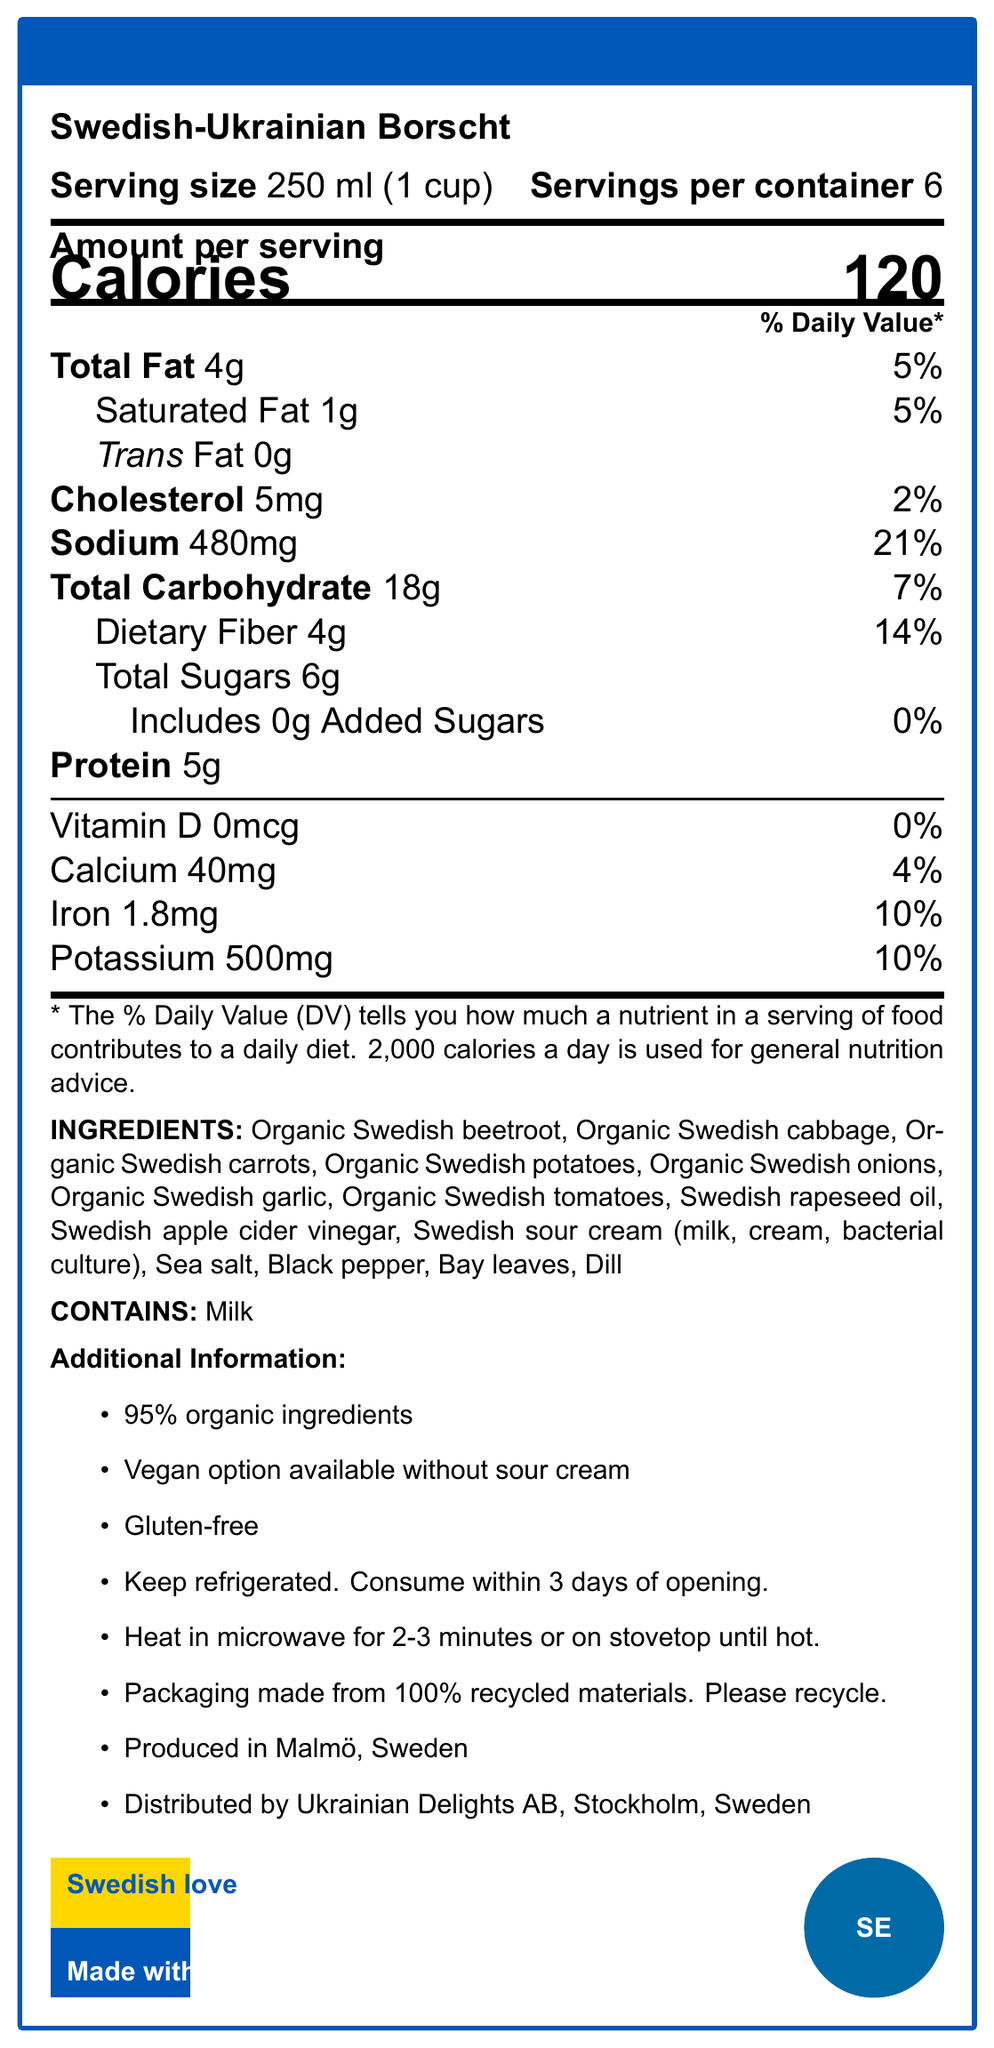what is the serving size? The serving size is clearly stated in the document as "250 ml (1 cup)".
Answer: 250 ml (1 cup) how many servings per container are there? The document shows that there are 6 servings per container.
Answer: 6 how many calories are in one serving of Swedish-Ukrainian Borscht? The document states that one serving contains 120 calories.
Answer: 120 what is the amount of sodium per serving and its daily value percentage? The document lists the sodium content as 480mg per serving, which is 21% of the daily value.
Answer: 480mg, 21% which allergens are present in the Borscht? The allergen information in the document states that the Borscht contains milk.
Answer: Milk list some of the key ingredients in the Swedish-Ukrainian Borscht. The document lists these ingredients clearly in the ingredients section.
Answer: Organic Swedish beetroot, Organic Swedish cabbage, Organic Swedish carrots, Organic Swedish potatoes, Organic Swedish onions, Organic Swedish garlic, Organic Swedish tomatoes what is the amount of dietary fiber per serving, and what percentage of the daily value does it contribute? The dietary fiber per serving is 4g, contributing to 14% of the daily value.
Answer: 4g, 14% where is the Borscht produced and distributed? The document states that the Borscht is produced in Malmö, Sweden, and distributed by Ukrainian Delights AB, Stockholm, Sweden.
Answer: Produced in Malmö, Sweden; Distributed by Ukrainian Delights AB, Stockholm, Sweden which of the following is true about the product?
A. It contains gluten.
B. It has a vegan option available.
C. It is made from 100% organic ingredients.
D. It contains preservatives. The document states that a vegan option is available without sour cream, making B the correct answer.
Answer: B how many grams of total carbohydrates are in a serving? 
A. 12g
B. 15g
C. 18g
D. 20g The document mentions that there are 18g of total carbohydrates per serving.
Answer: C does the product include any added sugars? The document explicitly states that there are no added sugars in the product.
Answer: No is the packaging made from recycled materials? The document notes that the packaging is made from 100% recycled materials.
Answer: Yes summarize the main idea of the document. The document serves to inform the consumer about the nutritional and ingredient details of the product, as well as special considerations regarding dietary options and packaging sustainability.
Answer: The document provides detailed nutrition facts for a traditional Ukrainian borscht adapted with Swedish ingredients. It includes information on serving size, nutritional content per serving, ingredient list, allergen warnings, and additional information such as storage tips, heating instructions, and sustainability notes. what is the percentage of daily value for calcium per serving? The document shows that the calcium content per serving is 40mg, which is 4% of the daily value.
Answer: 4% how many calories would be consumed if you ate the entire container? Since there are 120 calories per serving and 6 servings per container, consuming the entire container would be 120 calories/serving * 6 servings = 720 calories.
Answer: 720 calories is the product gluten-free? The document states that the product is gluten-free in the additional information section.
Answer: Yes what proportion of the ingredients are organic? The document mentions that 95% of the ingredients are organic.
Answer: 95% are there any other allergens besides milk? The document only lists milk as an allergen, but it does not provide comprehensive information on potential cross-contamination or other allergens.
Answer: Not enough information 